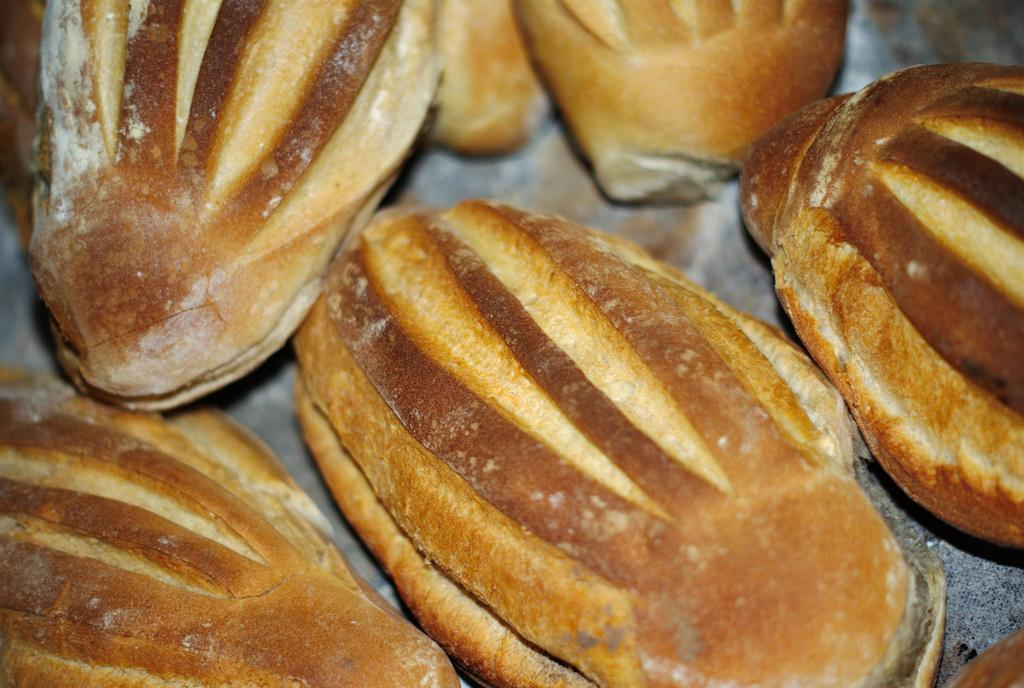What type of items can be seen in the image? There are food items in the image. What color are the food items? The color of the food items is brown. Can you describe the quality of the image? The image is slightly blurry in the background. Are there any plants growing in the food items in the image? There are no plants visible in the image, and the food items are not depicted as growing plants. 